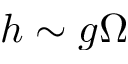Convert formula to latex. <formula><loc_0><loc_0><loc_500><loc_500>h \sim g \Omega</formula> 